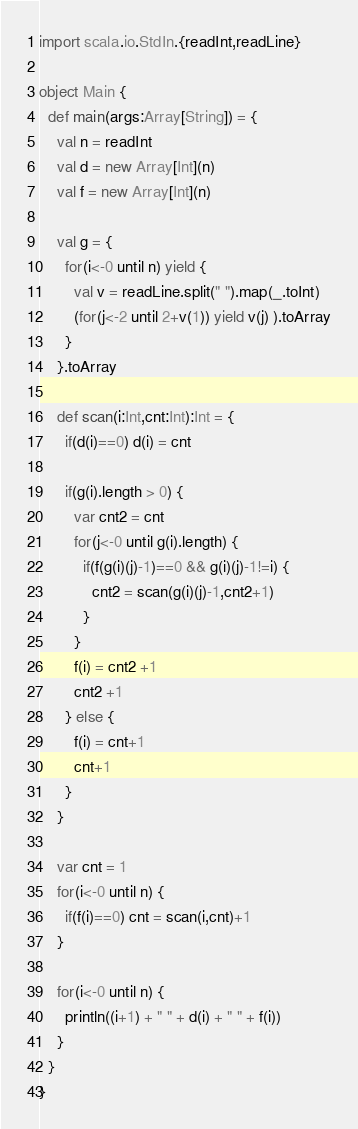<code> <loc_0><loc_0><loc_500><loc_500><_Scala_>import scala.io.StdIn.{readInt,readLine}
  
object Main {
  def main(args:Array[String]) = {
    val n = readInt
    val d = new Array[Int](n)
    val f = new Array[Int](n)

    val g = {
      for(i<-0 until n) yield {
        val v = readLine.split(" ").map(_.toInt)
        (for(j<-2 until 2+v(1)) yield v(j) ).toArray
      }
    }.toArray

    def scan(i:Int,cnt:Int):Int = {
      if(d(i)==0) d(i) = cnt

      if(g(i).length > 0) {
        var cnt2 = cnt
        for(j<-0 until g(i).length) {
          if(f(g(i)(j)-1)==0 && g(i)(j)-1!=i) {
            cnt2 = scan(g(i)(j)-1,cnt2+1)
          }
        }
        f(i) = cnt2 +1
        cnt2 +1
      } else {
        f(i) = cnt+1
        cnt+1
      }
    }

    var cnt = 1
    for(i<-0 until n) {
      if(f(i)==0) cnt = scan(i,cnt)+1
    }

    for(i<-0 until n) {
      println((i+1) + " " + d(i) + " " + f(i))
    }
  }
}</code> 